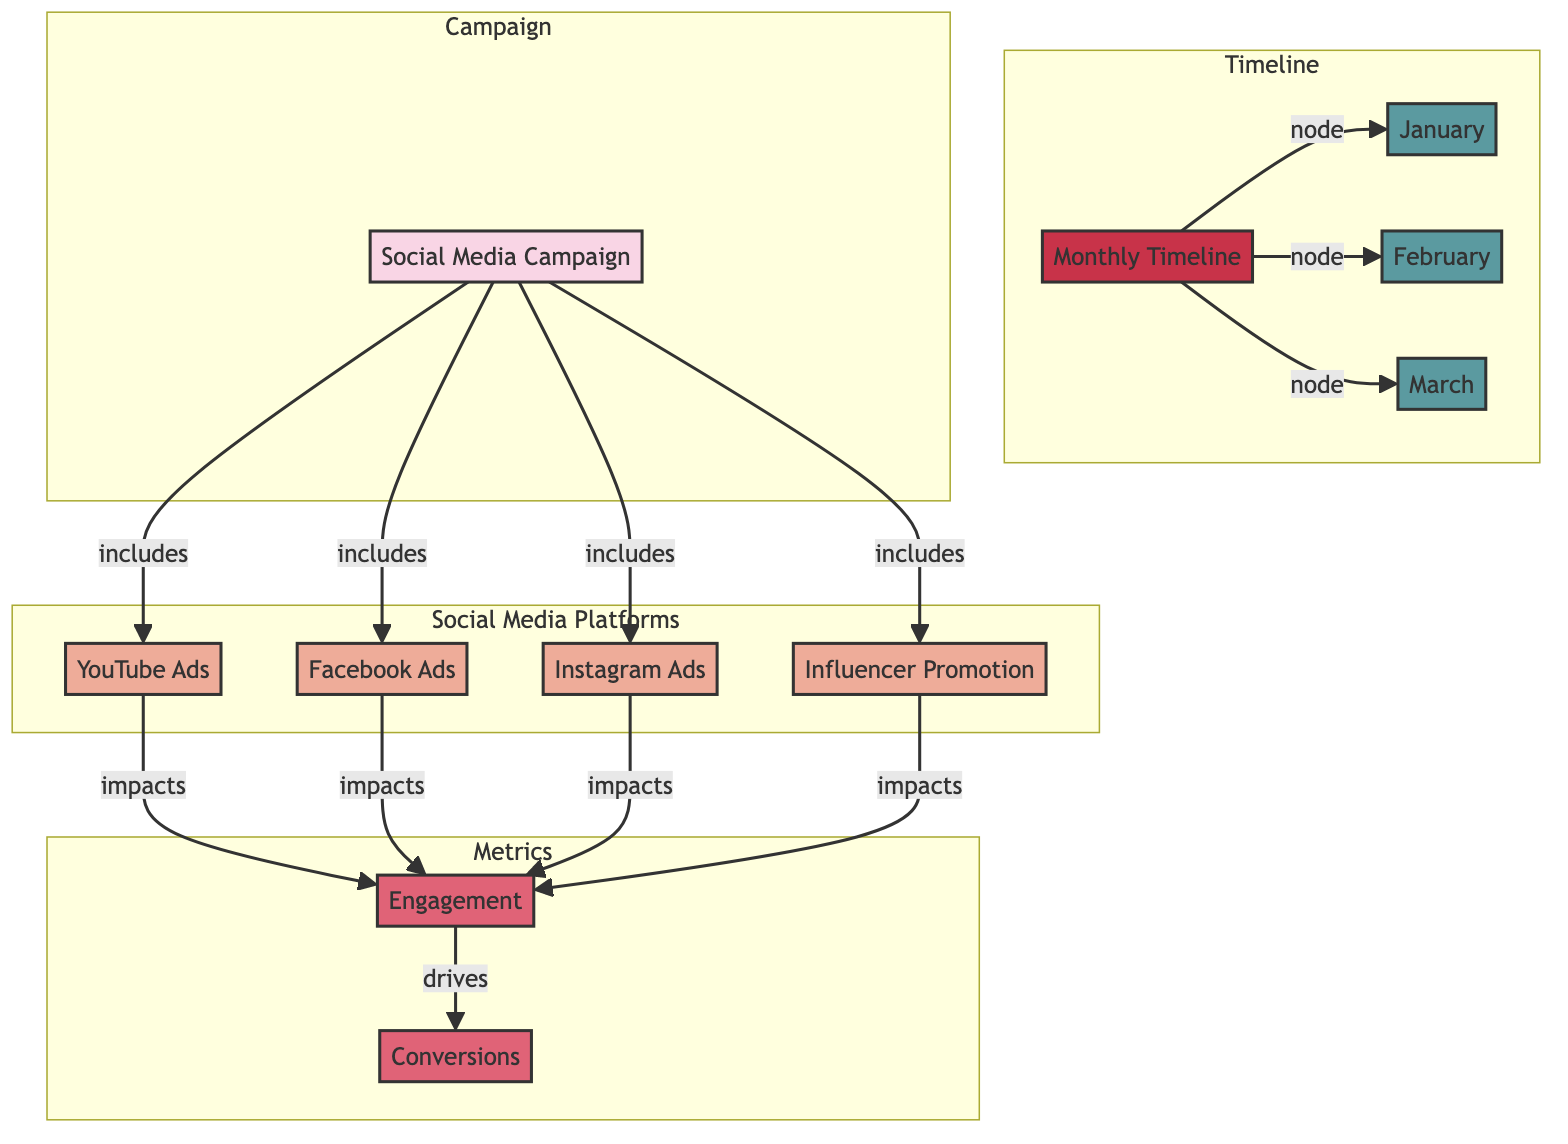What are the components included in the social media campaign? The campaign includes YouTube Ads, Facebook Ads, Instagram Ads, and Influencer Promotion as depicted by the edges connecting these nodes to the campaign node.
Answer: YouTube Ads, Facebook Ads, Instagram Ads, Influencer Promotion How many social media platforms are depicted in the diagram? By counting the nodes that fall under the "Social Media Platforms" subgraph, we identify four distinct platforms: YouTube, Facebook, Instagram, and Influencer Promotion.
Answer: 4 What is the impact of social media platforms on engagement? All social media platforms (YouTube Ads, Facebook Ads, Instagram Ads, Influencer Promotion) are shown to have a direct edge to the Engagement node, indicating that they all impact engagement equally.
Answer: Engagement How does engagement relate to conversions? The Engagement node drives the Conversions node, as indicated by the edge connecting these two nodes. This shows that higher engagement is expected to lead to more conversions.
Answer: Drives Which month is the last in the timeline? The timeline node includes three month nodes: January, February, and March. Looking at the arrangement, March is the last month in this sequence.
Answer: March What kind of relationship exists between the social media platforms and the social media campaign? There are multiple edges from each social media platform to the social media campaign node, indicating that these platforms are part of the campaign strategy. The relationship is inclusive.
Answer: Inclusive How many metrics are represented in the diagram? The Metrics subgraph consists of two nodes: Engagement and Conversions. Therefore, we identify two metrics represented within the diagram.
Answer: 2 Which node is directly impacted by social media advertising? All four social media advertising nodes (YouTube Ads, Facebook Ads, Instagram Ads, Influencer Promotion) impact the Engagement node, as seen from the connecting edges.
Answer: Engagement What is the function of the timeline in the diagram? The timeline organizes the months of the campaign, indicating when the results or data related to the campaign will be evaluated, ensuring a chronological flow of information.
Answer: Nodes for months 